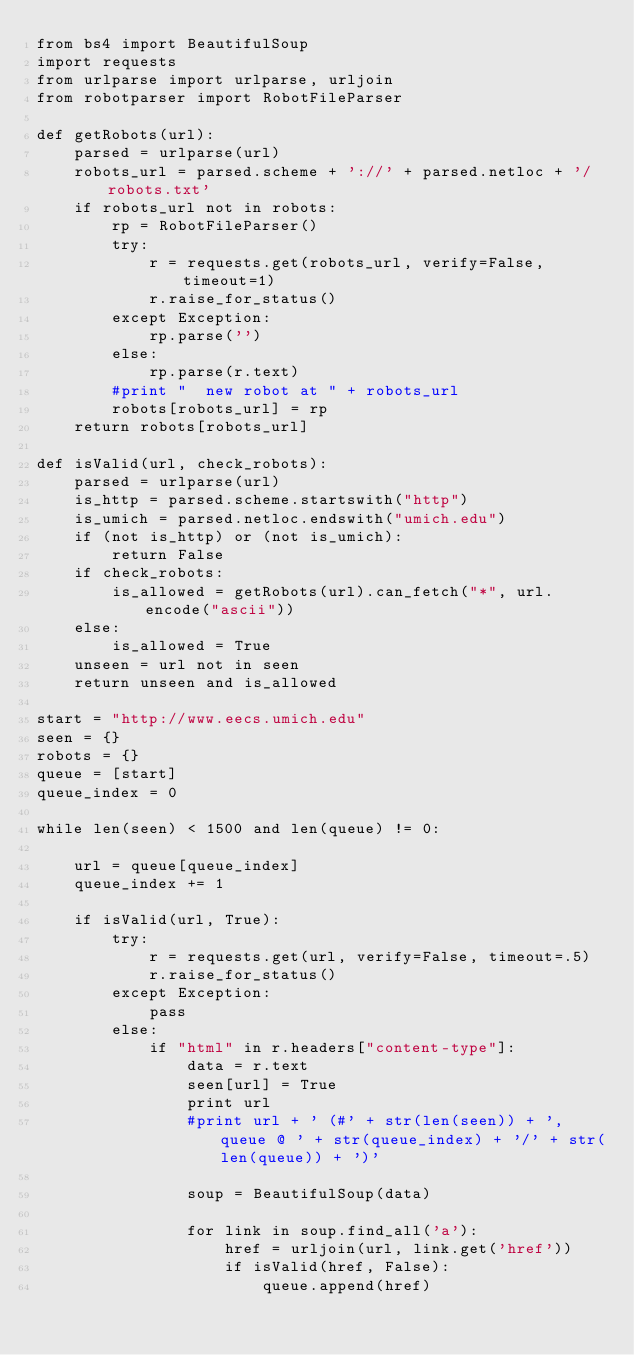Convert code to text. <code><loc_0><loc_0><loc_500><loc_500><_Python_>from bs4 import BeautifulSoup
import requests
from urlparse import urlparse, urljoin
from robotparser import RobotFileParser

def getRobots(url):
    parsed = urlparse(url)
    robots_url = parsed.scheme + '://' + parsed.netloc + '/robots.txt'
    if robots_url not in robots:
        rp = RobotFileParser()
        try:
            r = requests.get(robots_url, verify=False, timeout=1)
            r.raise_for_status()
        except Exception:
            rp.parse('')
        else:
            rp.parse(r.text)
        #print "  new robot at " + robots_url
        robots[robots_url] = rp
    return robots[robots_url]

def isValid(url, check_robots):
    parsed = urlparse(url)
    is_http = parsed.scheme.startswith("http")
    is_umich = parsed.netloc.endswith("umich.edu")
    if (not is_http) or (not is_umich):
        return False
    if check_robots:
        is_allowed = getRobots(url).can_fetch("*", url.encode("ascii"))
    else:
        is_allowed = True
    unseen = url not in seen
    return unseen and is_allowed

start = "http://www.eecs.umich.edu"
seen = {}
robots = {}
queue = [start]
queue_index = 0

while len(seen) < 1500 and len(queue) != 0:

    url = queue[queue_index]
    queue_index += 1

    if isValid(url, True):
        try:
            r = requests.get(url, verify=False, timeout=.5)
            r.raise_for_status()
        except Exception:
            pass
        else:
            if "html" in r.headers["content-type"]:
                data = r.text
                seen[url] = True
                print url
                #print url + ' (#' + str(len(seen)) + ', queue @ ' + str(queue_index) + '/' + str(len(queue)) + ')'

                soup = BeautifulSoup(data)

                for link in soup.find_all('a'):
                    href = urljoin(url, link.get('href'))
                    if isValid(href, False):
                        queue.append(href)
</code> 